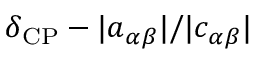Convert formula to latex. <formula><loc_0><loc_0><loc_500><loc_500>\delta _ { C P } - | a _ { \alpha \beta } | / | c _ { \alpha \beta } |</formula> 